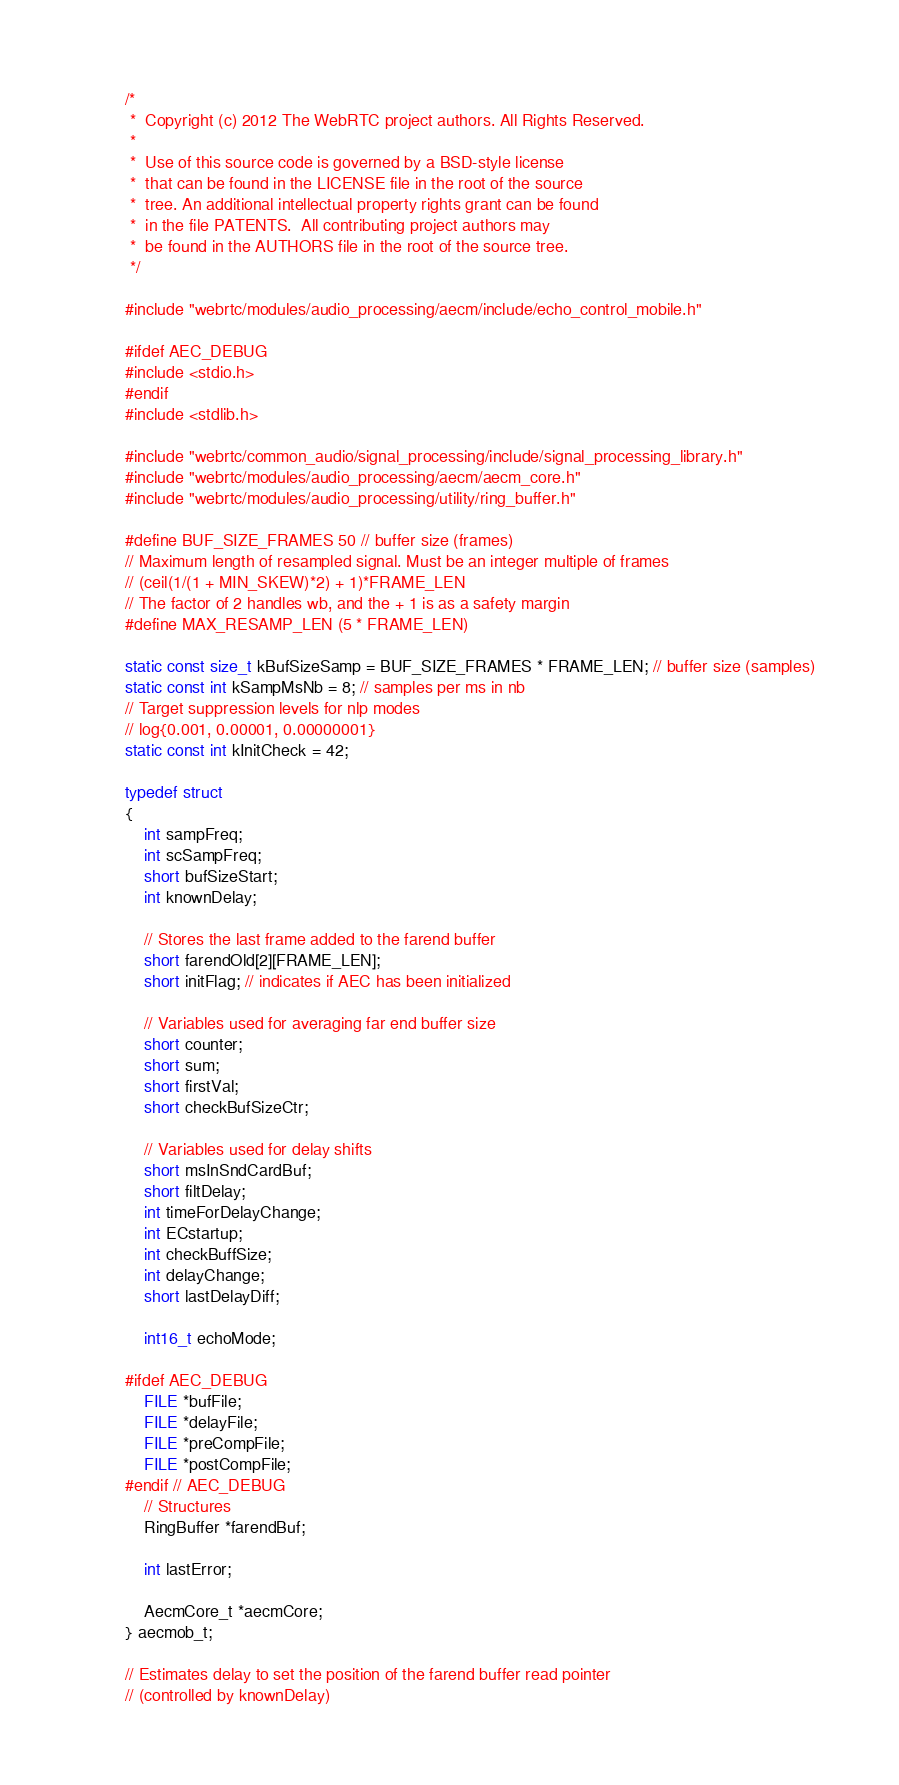<code> <loc_0><loc_0><loc_500><loc_500><_C_>/*
 *  Copyright (c) 2012 The WebRTC project authors. All Rights Reserved.
 *
 *  Use of this source code is governed by a BSD-style license
 *  that can be found in the LICENSE file in the root of the source
 *  tree. An additional intellectual property rights grant can be found
 *  in the file PATENTS.  All contributing project authors may
 *  be found in the AUTHORS file in the root of the source tree.
 */

#include "webrtc/modules/audio_processing/aecm/include/echo_control_mobile.h"

#ifdef AEC_DEBUG
#include <stdio.h>
#endif
#include <stdlib.h>

#include "webrtc/common_audio/signal_processing/include/signal_processing_library.h"
#include "webrtc/modules/audio_processing/aecm/aecm_core.h"
#include "webrtc/modules/audio_processing/utility/ring_buffer.h"

#define BUF_SIZE_FRAMES 50 // buffer size (frames)
// Maximum length of resampled signal. Must be an integer multiple of frames
// (ceil(1/(1 + MIN_SKEW)*2) + 1)*FRAME_LEN
// The factor of 2 handles wb, and the + 1 is as a safety margin
#define MAX_RESAMP_LEN (5 * FRAME_LEN)

static const size_t kBufSizeSamp = BUF_SIZE_FRAMES * FRAME_LEN; // buffer size (samples)
static const int kSampMsNb = 8; // samples per ms in nb
// Target suppression levels for nlp modes
// log{0.001, 0.00001, 0.00000001}
static const int kInitCheck = 42;

typedef struct
{
    int sampFreq;
    int scSampFreq;
    short bufSizeStart;
    int knownDelay;

    // Stores the last frame added to the farend buffer
    short farendOld[2][FRAME_LEN];
    short initFlag; // indicates if AEC has been initialized

    // Variables used for averaging far end buffer size
    short counter;
    short sum;
    short firstVal;
    short checkBufSizeCtr;

    // Variables used for delay shifts
    short msInSndCardBuf;
    short filtDelay;
    int timeForDelayChange;
    int ECstartup;
    int checkBuffSize;
    int delayChange;
    short lastDelayDiff;

    int16_t echoMode;

#ifdef AEC_DEBUG
    FILE *bufFile;
    FILE *delayFile;
    FILE *preCompFile;
    FILE *postCompFile;
#endif // AEC_DEBUG
    // Structures
    RingBuffer *farendBuf;

    int lastError;

    AecmCore_t *aecmCore;
} aecmob_t;

// Estimates delay to set the position of the farend buffer read pointer
// (controlled by knownDelay)</code> 